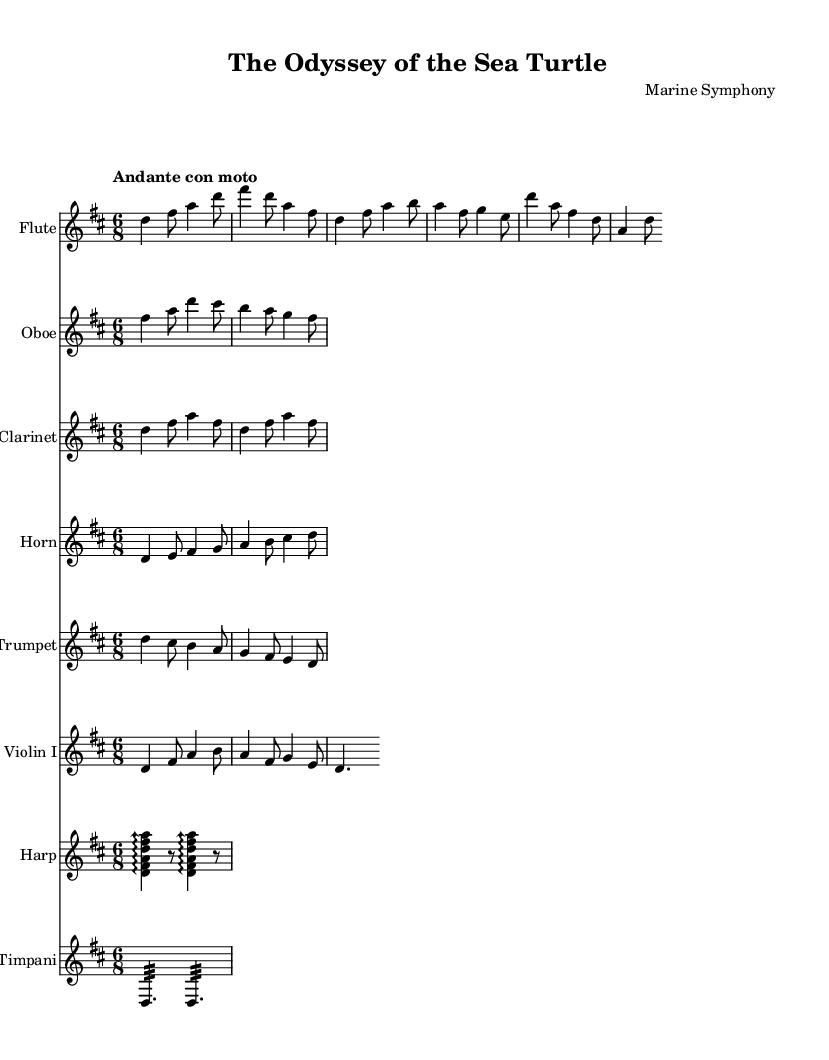What is the key signature of this music? The key signature is indicated in the global settings at the beginning of the score, which specifies the key as D major. D major has two sharps: F# and C#.
Answer: D major What is the time signature of this music? The time signature is also found in the global settings. It shows 6/8, meaning there are six eighth notes in each measure.
Answer: 6/8 What is the tempo marking for this piece? The tempo marking is stated as "Andante con moto" in the global settings. "Andante" generally indicates a moderately slow tempo, and "con moto" adds a sense of motion.
Answer: Andante con moto How many instruments are in this score? The score includes multiple staves, each representing a distinct instrument. By counting the individual staves under the \score block, we find there are eight instruments listed: Flute, Oboe, Clarinet, Horn, Trumpet, Violin I, Harp, and Timpani.
Answer: Eight Which instrument plays the theme first? The first instance of a thematic idea appears in the flute part within the Introduction section, which plays a melody that serves as the basis for further development.
Answer: Flute What special effect is indicated for the harp part? The harp part specifies “\arpeggioArrowUp”, which indicates that the notes should be played as arpeggios, resembling the sparkling quality of water.
Answer: Sparkling water What thematic section is the clarinet presenting? The clarinet plays a simplified part that echoes the earlier themes, featured in the passage outlined in its staff, and is predominantly repetitive in nature.
Answer: Simplified part 